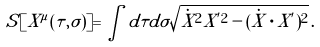<formula> <loc_0><loc_0><loc_500><loc_500>S [ X ^ { \mu } ( \tau , \sigma ) ] = \int d \tau d \sigma \sqrt { \dot { X } ^ { 2 } X ^ { ^ { \prime } 2 } - ( \dot { X } \cdot X ^ { ^ { \prime } } ) ^ { 2 } } \, .</formula> 